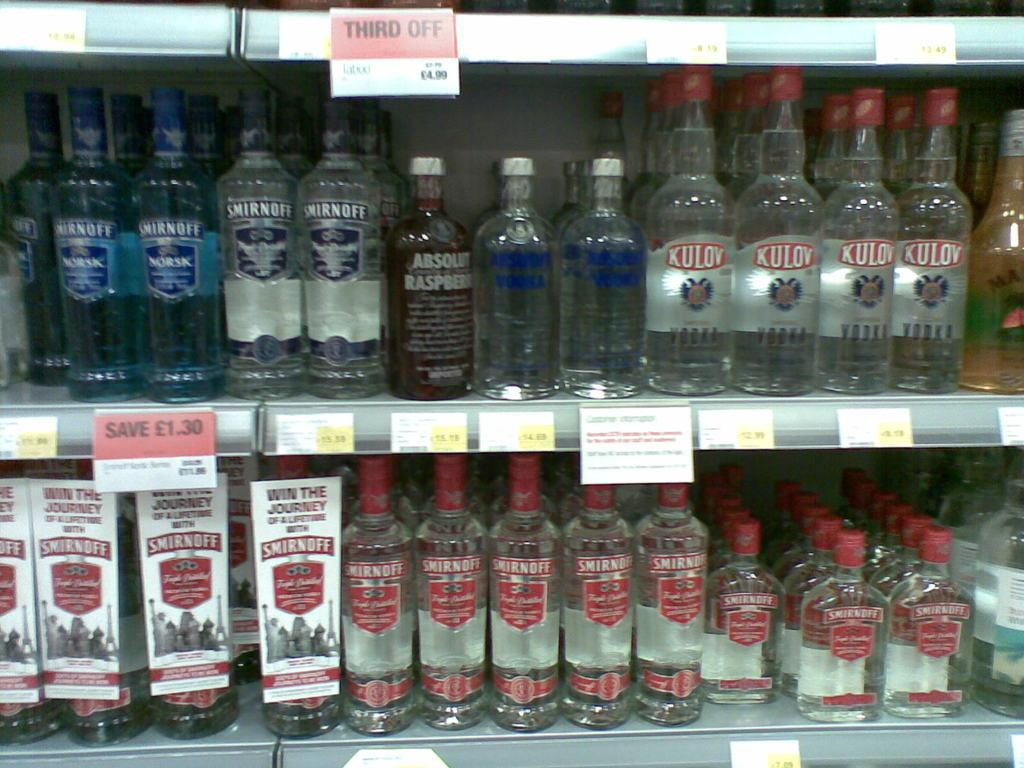<image>
Create a compact narrative representing the image presented. Bottles of alcohol line store shelves including Smirnoff on the bottom shelf. 